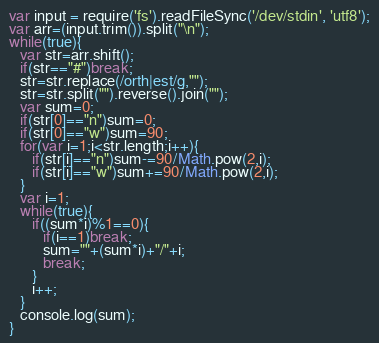<code> <loc_0><loc_0><loc_500><loc_500><_JavaScript_>var input = require('fs').readFileSync('/dev/stdin', 'utf8');
var arr=(input.trim()).split("\n");
while(true){
   var str=arr.shift();
   if(str=="#")break;
   str=str.replace(/orth|est/g,"");
   str=str.split("").reverse().join("");
   var sum=0;
   if(str[0]=="n")sum=0;
   if(str[0]=="w")sum=90;
   for(var i=1;i<str.length;i++){
      if(str[i]=="n")sum-=90/Math.pow(2,i);
      if(str[i]=="w")sum+=90/Math.pow(2,i);
   }
   var i=1;
   while(true){
      if((sum*i)%1==0){
         if(i==1)break;
         sum=""+(sum*i)+"/"+i;
         break;
      }
      i++;
   }
   console.log(sum);
}</code> 